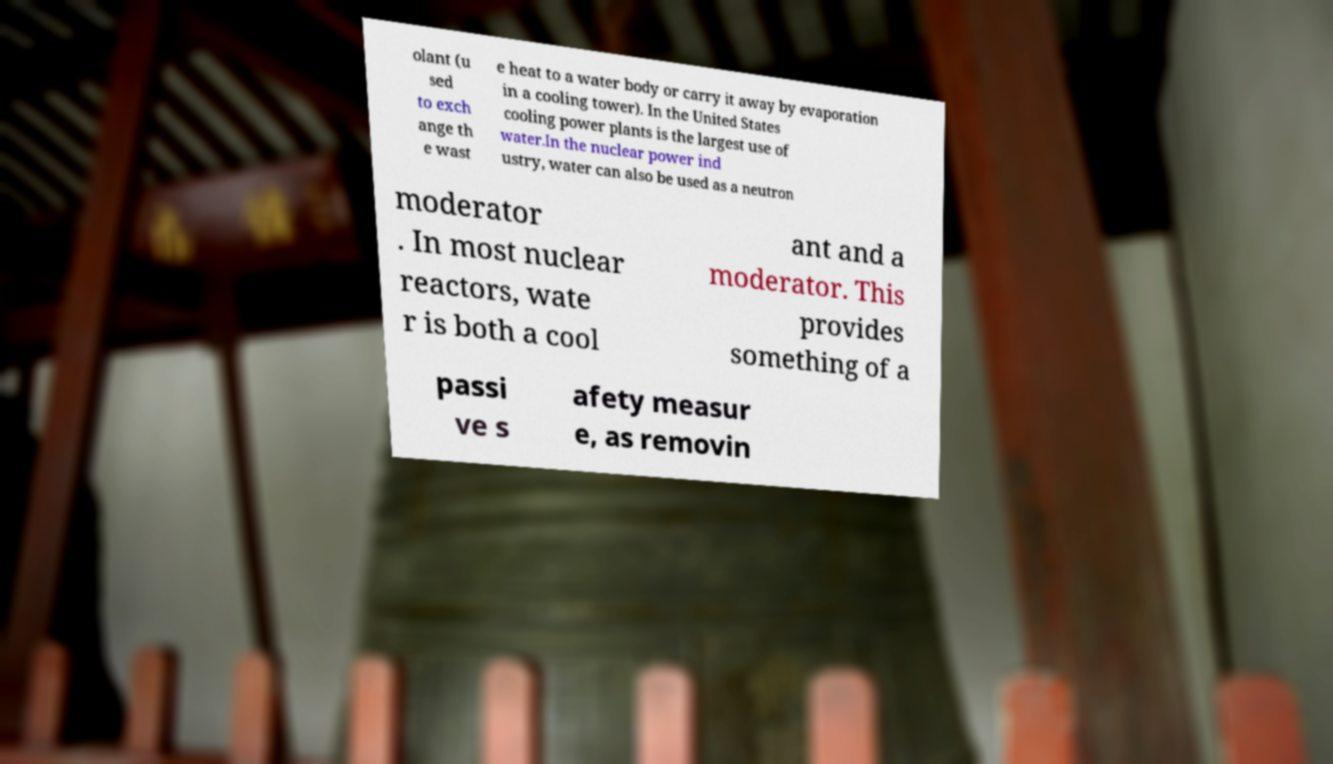Could you assist in decoding the text presented in this image and type it out clearly? olant (u sed to exch ange th e wast e heat to a water body or carry it away by evaporation in a cooling tower). In the United States cooling power plants is the largest use of water.In the nuclear power ind ustry, water can also be used as a neutron moderator . In most nuclear reactors, wate r is both a cool ant and a moderator. This provides something of a passi ve s afety measur e, as removin 